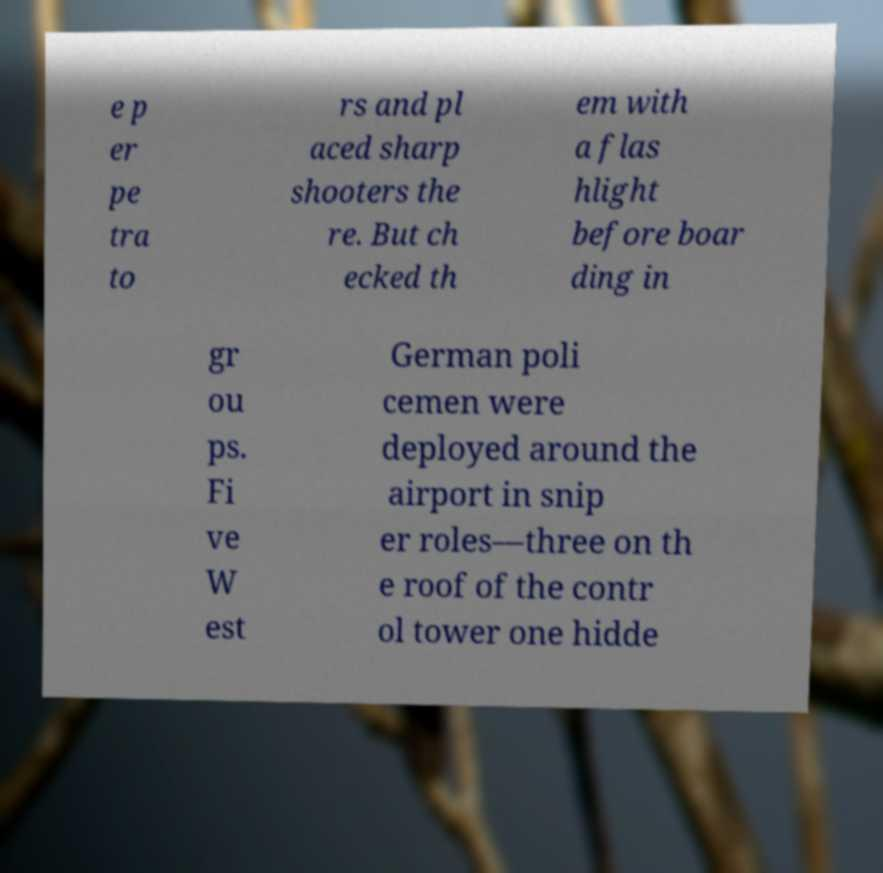Please read and relay the text visible in this image. What does it say? e p er pe tra to rs and pl aced sharp shooters the re. But ch ecked th em with a flas hlight before boar ding in gr ou ps. Fi ve W est German poli cemen were deployed around the airport in snip er roles—three on th e roof of the contr ol tower one hidde 